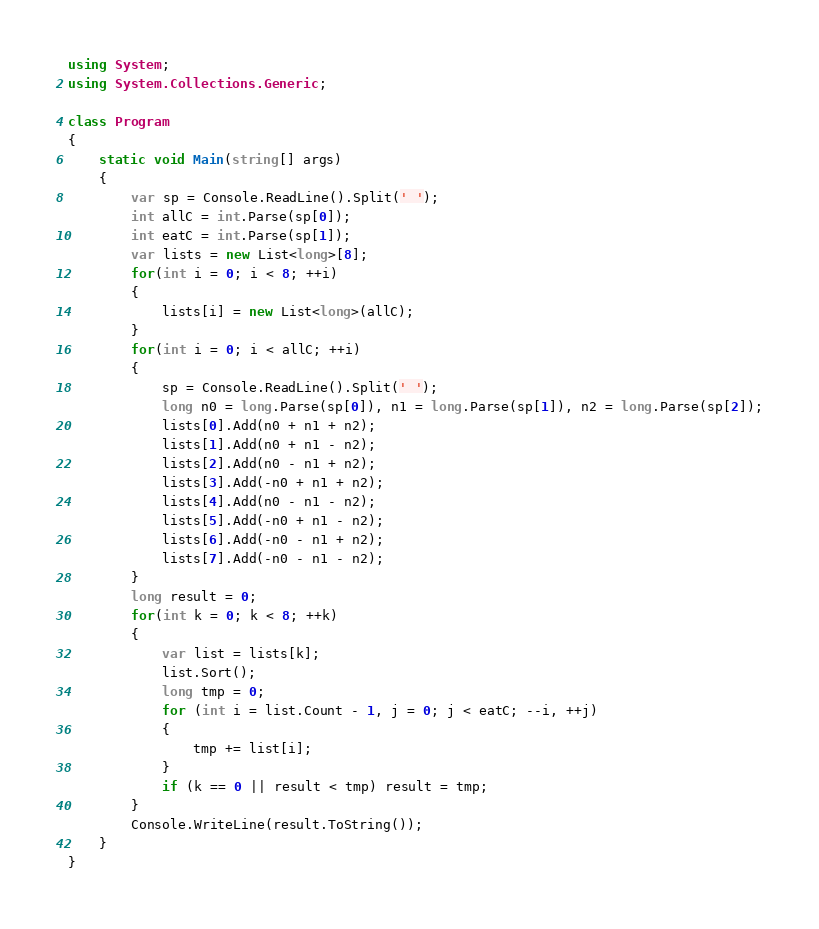<code> <loc_0><loc_0><loc_500><loc_500><_C#_>using System;
using System.Collections.Generic;

class Program
{
    static void Main(string[] args)
    {
        var sp = Console.ReadLine().Split(' ');
        int allC = int.Parse(sp[0]);
        int eatC = int.Parse(sp[1]);
        var lists = new List<long>[8];
        for(int i = 0; i < 8; ++i)
        {
            lists[i] = new List<long>(allC);
        }
        for(int i = 0; i < allC; ++i)
        {
            sp = Console.ReadLine().Split(' ');
            long n0 = long.Parse(sp[0]), n1 = long.Parse(sp[1]), n2 = long.Parse(sp[2]);
            lists[0].Add(n0 + n1 + n2);
            lists[1].Add(n0 + n1 - n2);
            lists[2].Add(n0 - n1 + n2);
            lists[3].Add(-n0 + n1 + n2);
            lists[4].Add(n0 - n1 - n2);
            lists[5].Add(-n0 + n1 - n2);
            lists[6].Add(-n0 - n1 + n2);
            lists[7].Add(-n0 - n1 - n2);
        }
        long result = 0;
        for(int k = 0; k < 8; ++k)
        {
            var list = lists[k];
            list.Sort();
            long tmp = 0;
            for (int i = list.Count - 1, j = 0; j < eatC; --i, ++j)
            {
                tmp += list[i];
            }
            if (k == 0 || result < tmp) result = tmp;
        }
        Console.WriteLine(result.ToString());
    }
}
</code> 